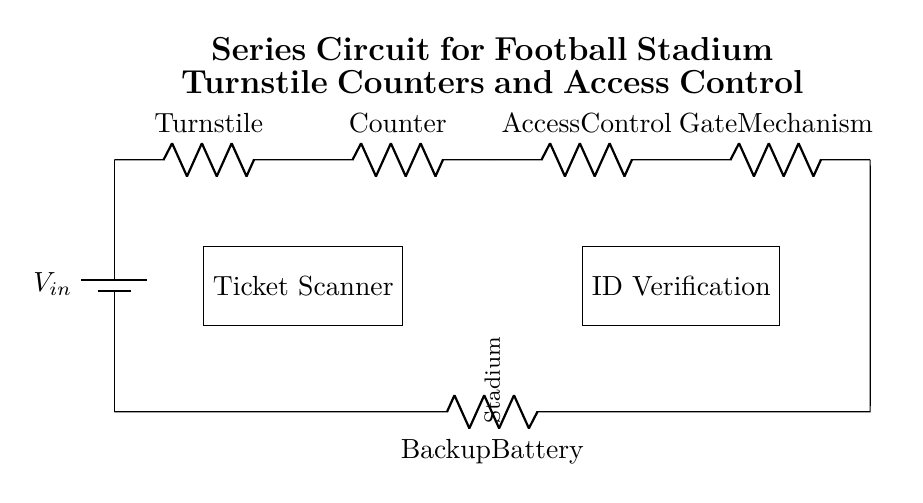What are the components in the circuit? The components visible in the circuit include a battery, three resistors labeled as Turnstile, Counter, Access Control, a battery labeled as Backup Battery, and two rectangular blocks labeled Ticket Scanner and ID Verification.
Answer: battery, Turnstile, Counter, Access Control, Gate Mechanism, Backup Battery, Ticket Scanner, ID Verification What does the Ticket Scanner do? The Ticket Scanner is represented as a rectangular block in the circuit and is tasked with scanning tickets for entry into the stadium.
Answer: scans tickets How many resistors are in the circuit? The circuit contains four resistors: Turnstile, Counter, Access Control, and Backup Battery. Counting them gives a total of four.
Answer: four What is the last component before closing the circuit? The last component before closing the circuit is the Gate Mechanism, which is the final resistor in the series before the circuit returns to the battery.
Answer: Gate Mechanism What is the function of the ID Verification component? The ID Verification component is meant to confirm the identity of individuals entering the stadium, as indicated by its labeled position in the circuit.
Answer: confirm identity What type of circuit is represented in the diagram? The circuit is a series circuit, as indicated by the layout where components are connected end-to-end in a single path.
Answer: series circuit 